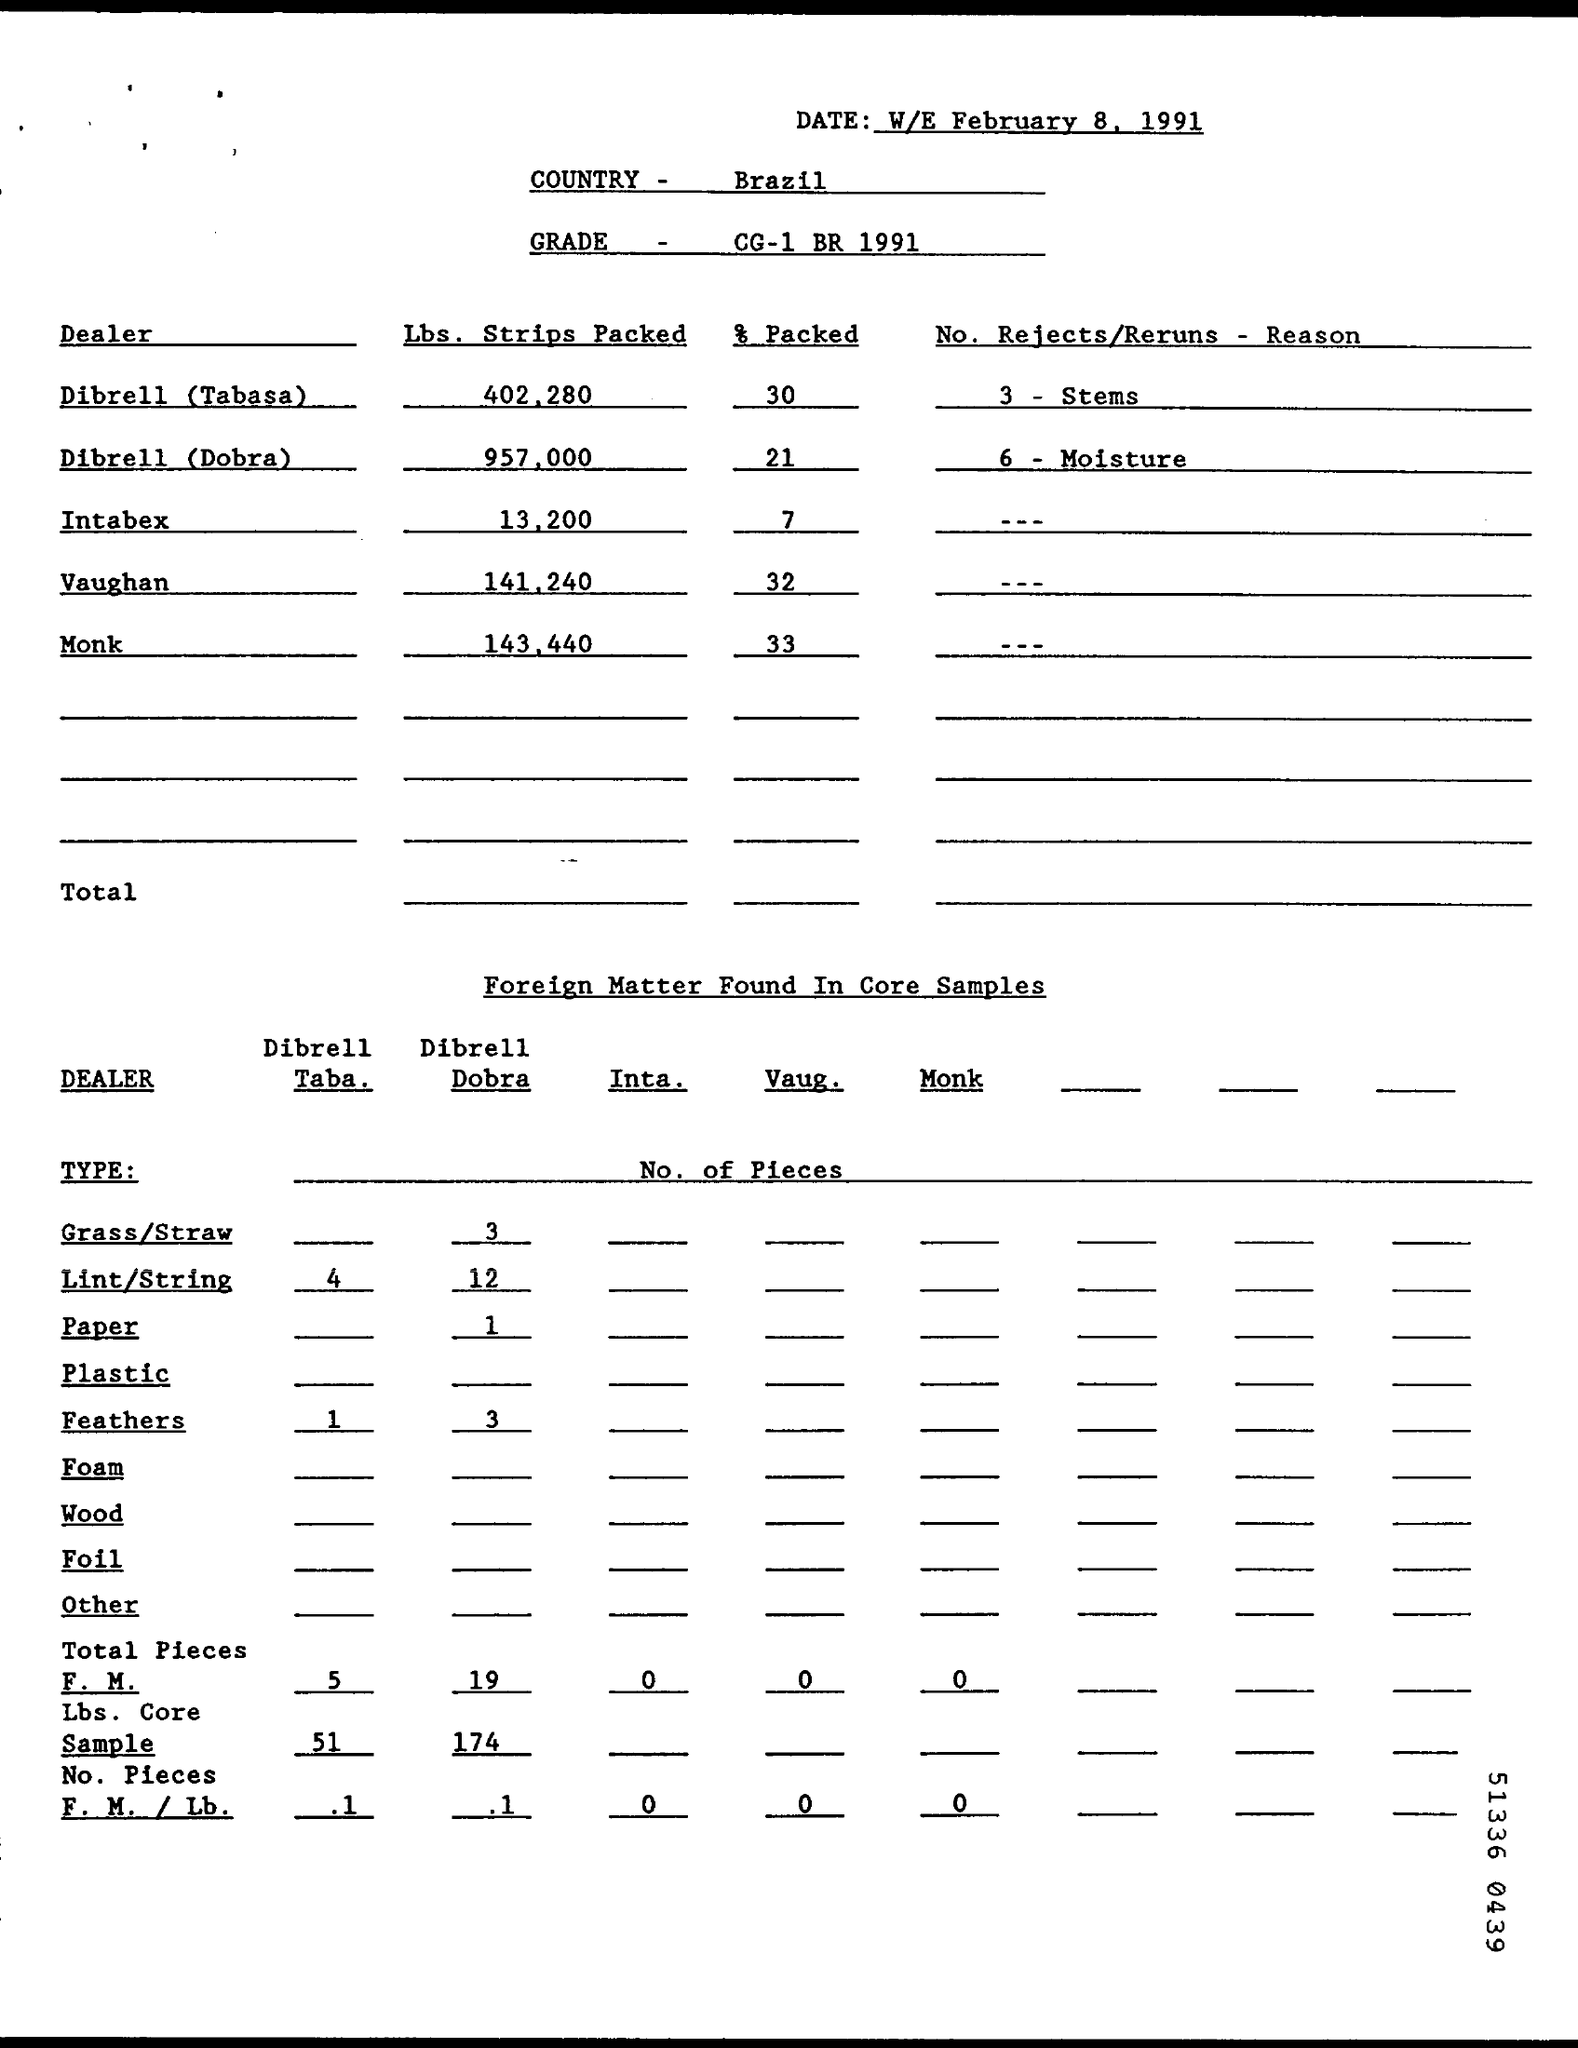When is the document dated?
Offer a terse response. W/E FEBRUARY 8, 1991. Which country is mentioned?
Provide a short and direct response. Brazil. What is the grade specified?
Offer a terse response. CG-1 BR 1991. What percentage was packed by Dibrell (Dobra)?
Your answer should be compact. 21. 